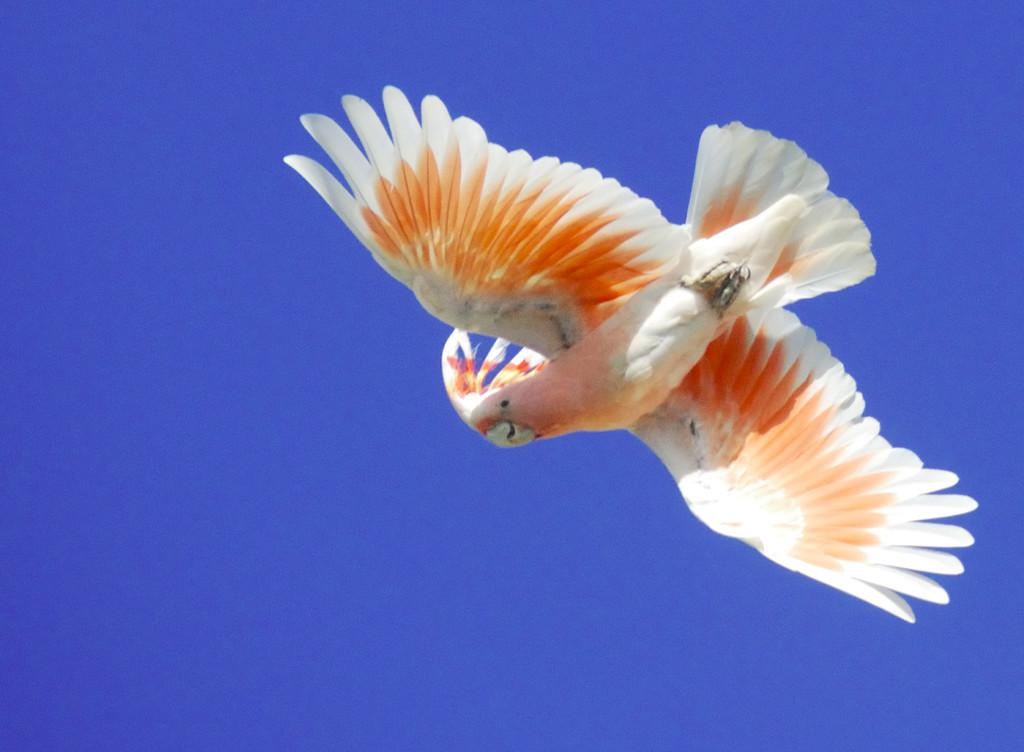What type of animal can be seen in the image? There is a bird in the image. What is the bird doing in the image? The bird is flying in the sky. What type of toy is the bird playing with in the image? There are no toys present in the image, as it features a bird flying in the sky. 